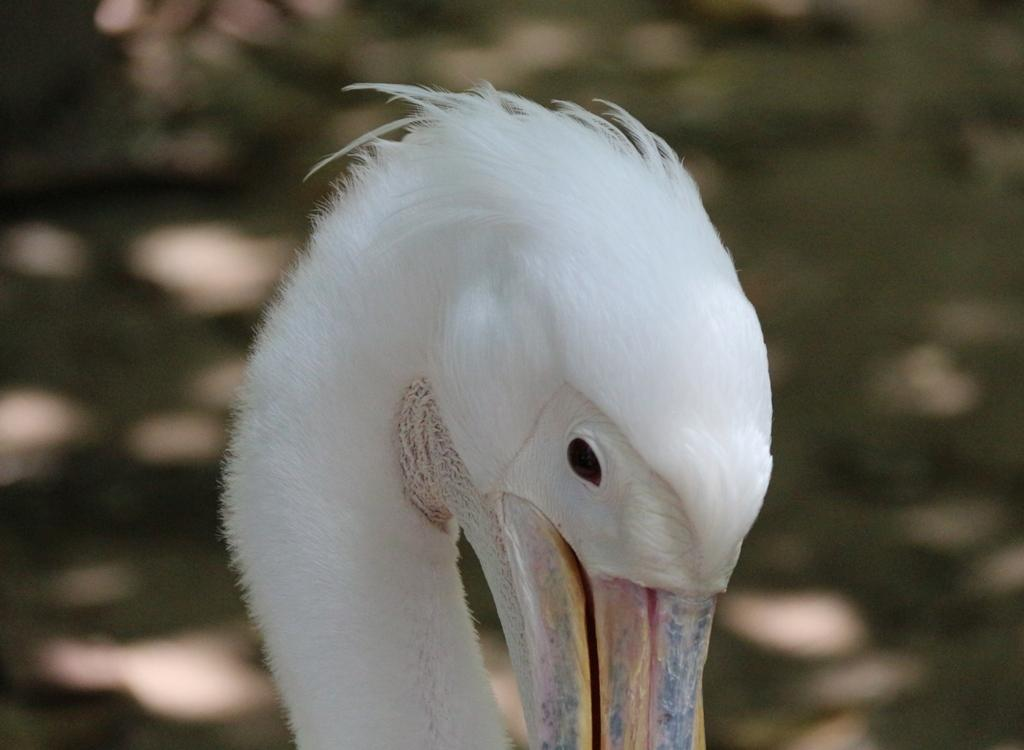What type of animal is present in the image? There is a bird in the image. Can you describe the background of the image? The background of the image is blurred. What type of soap is the bird using to clean its feathers in the image? There is no soap or indication of the bird cleaning its feathers in the image. What type of ring is the bird wearing on its leg in the image? There is no ring or indication of the bird wearing any jewelry in the image. 